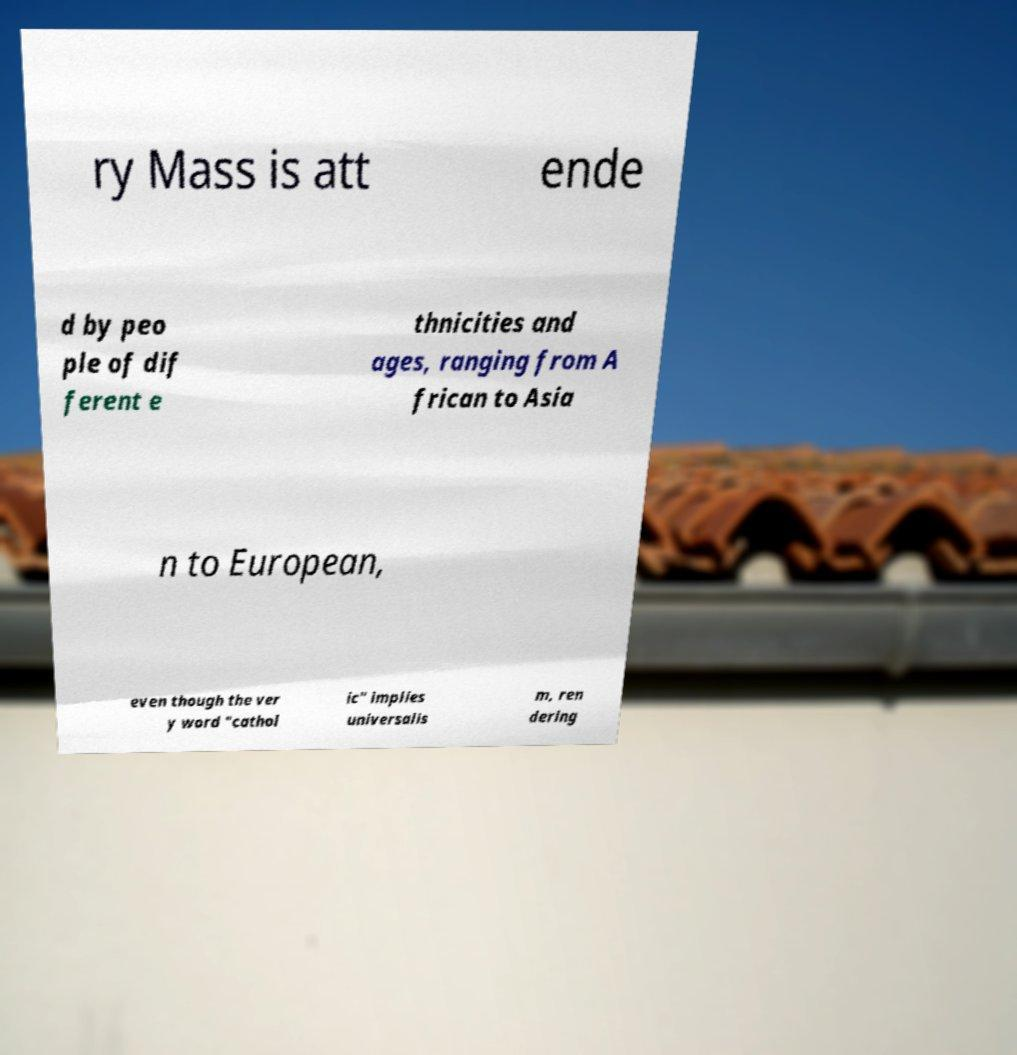Can you accurately transcribe the text from the provided image for me? ry Mass is att ende d by peo ple of dif ferent e thnicities and ages, ranging from A frican to Asia n to European, even though the ver y word "cathol ic" implies universalis m, ren dering 